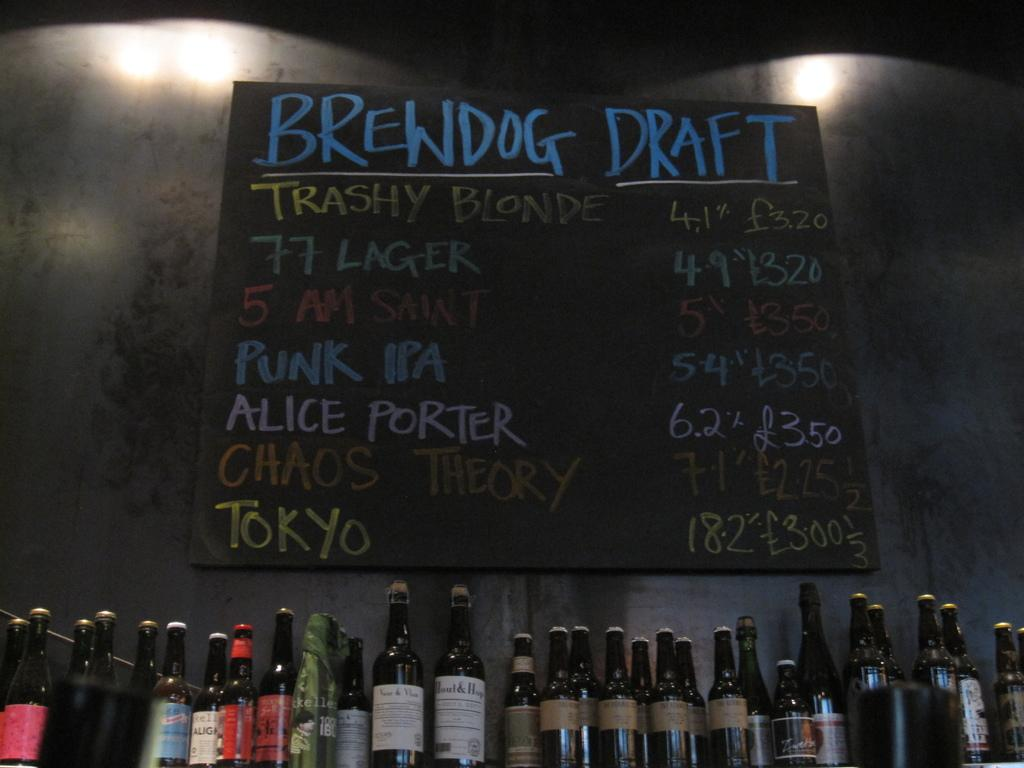Provide a one-sentence caption for the provided image. A black menu board showing the offerings of many types beer. 